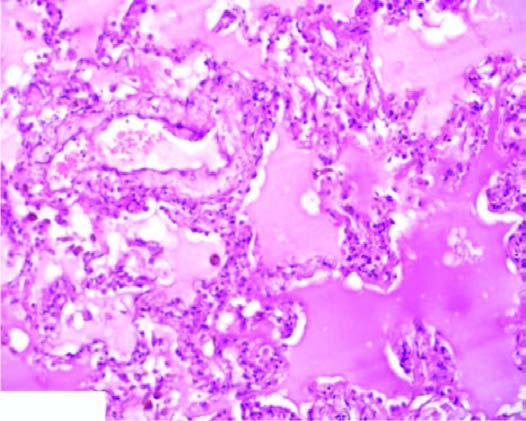do the alveolar spaces as well as interstitium contain eosinophilic, granular, homogeneous and pink proteinaceous oedema fluid along with some rbcs and inflammatory cells?
Answer the question using a single word or phrase. Yes 